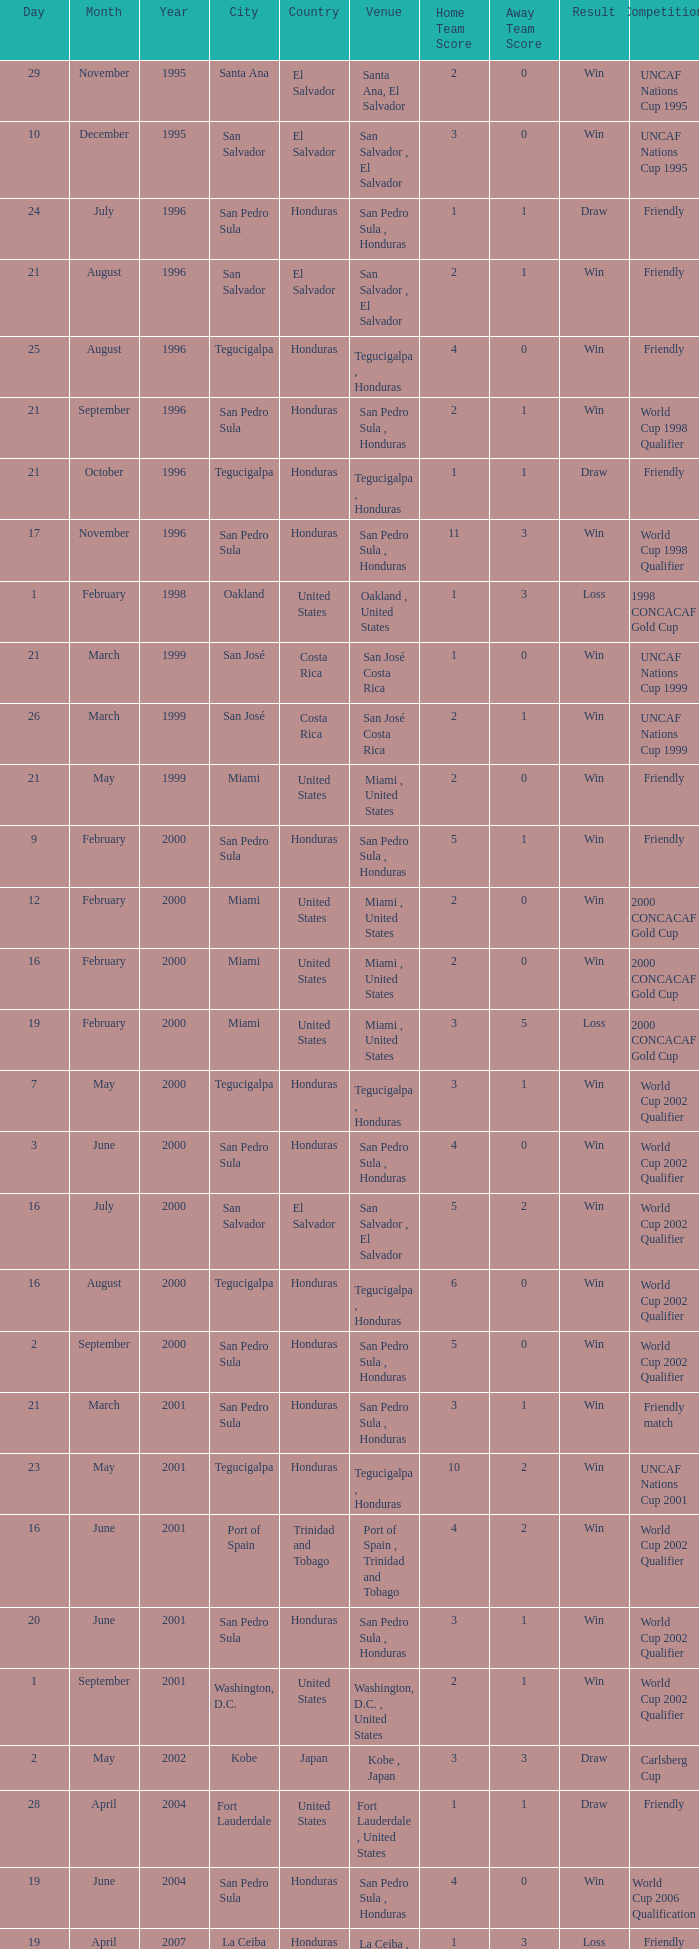Name the date of the uncaf nations cup 2009 26 January 2009. 